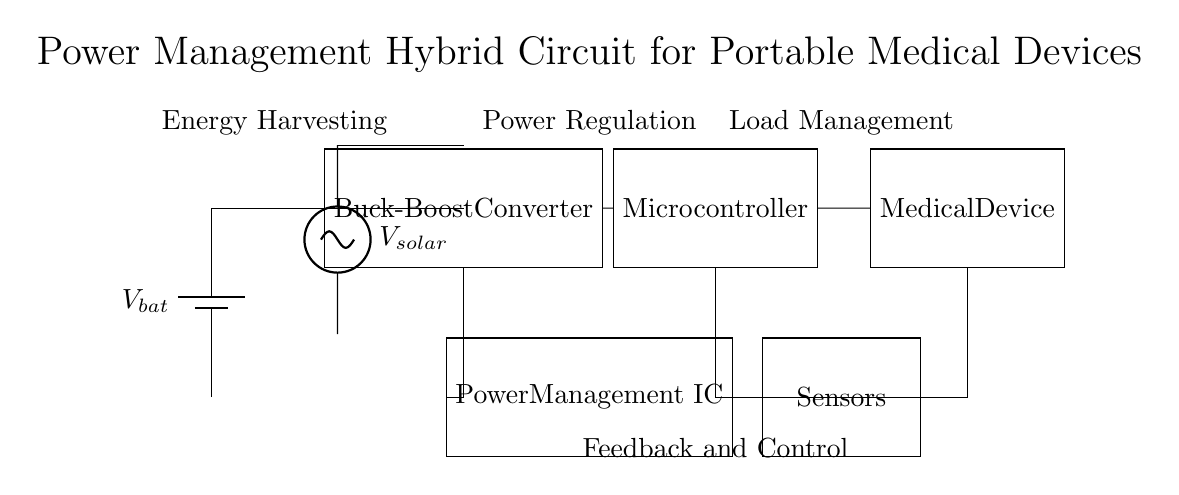What is the function of the Power Management IC? The Power Management IC regulates the power flow from the battery and solar panel to the microcontroller and load, ensuring efficient energy use.
Answer: Regulates power flow What components are used for energy harvesting? The energy harvesting components are the battery and the solar panel, which provide the necessary energy to power the circuit.
Answer: Battery and solar panel How does the Buck-Boost Converter operate in this circuit? The Buck-Boost Converter adjusts the voltage level of the input from the solar panel or battery, allowing the circuit to operate under various conditions and extend battery life.
Answer: Adjusts voltage levels What type of device is powered by this circuit? The device powered by this circuit is a medical device, which is indicated in the diagram as the load.
Answer: Medical device How does the Microcontroller interact with the Sensors? The Microcontroller receives data from the Sensors and processes it, enabling the device to function effectively by managing the operation based on that data.
Answer: Receives data What is the relationship between energy harvesting and load management in the circuit? Energy harvesting provides power to the system, while load management ensures that this power is used efficiently to operate the medical device without depleting the battery quickly.
Answer: Power source and efficiency What does the feedback mechanism entail? The feedback mechanism involves the Power Management IC monitoring the power levels and making adjustments to optimize performance and extend battery life.
Answer: Optimizes performance 